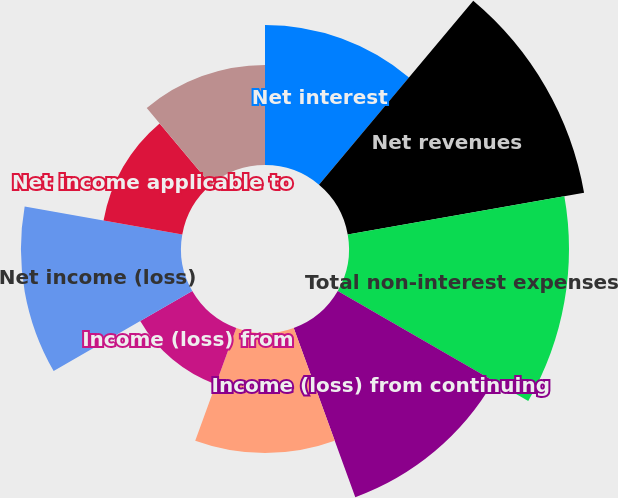Convert chart. <chart><loc_0><loc_0><loc_500><loc_500><pie_chart><fcel>Net interest<fcel>Net revenues<fcel>Total non-interest expenses<fcel>Income (loss) from continuing<fcel>Provision for (benefit from)<fcel>Income (loss) from<fcel>Net income (loss)<fcel>Net income applicable to<fcel>Preferred stock dividends and<nl><fcel>10.77%<fcel>18.46%<fcel>16.92%<fcel>13.85%<fcel>9.23%<fcel>4.62%<fcel>12.31%<fcel>6.15%<fcel>7.69%<nl></chart> 